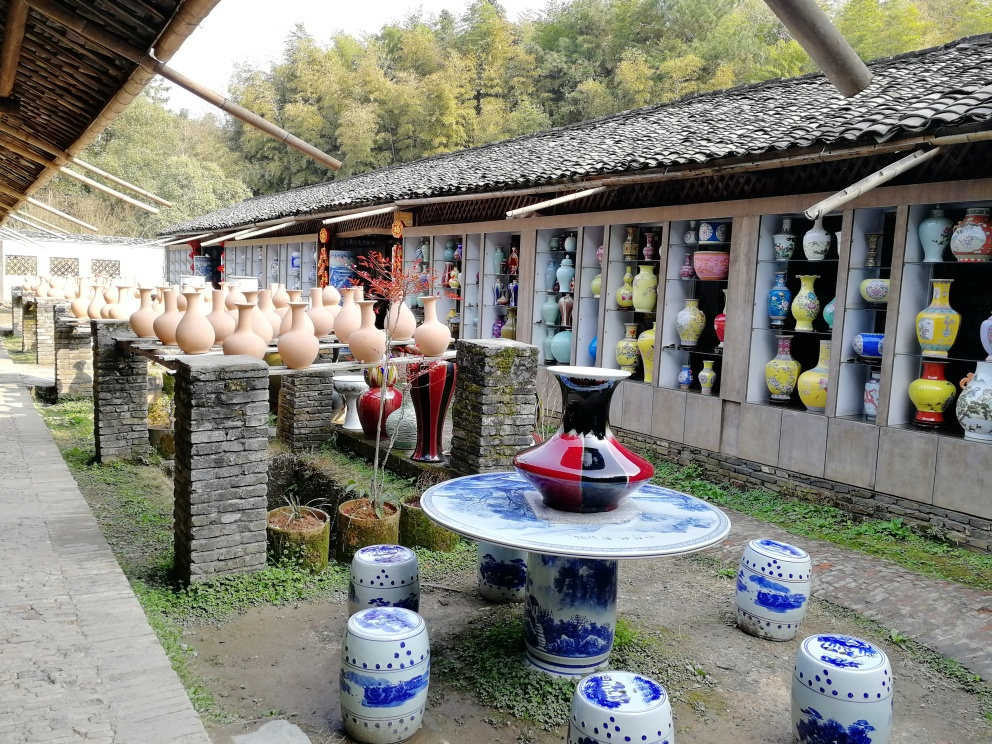What can you tell me about the types of ceramics in this picture? The image displays a variety of ceramics. Foremost are the unglazed, earthenware pots on the stone pillars, which appear functional and ready for practical use. In contrast, inside the building, there are glazed and intricately painted vases, some with floral motifs and others with more abstract designs, indicating a level of artistic skill and possibly suggesting these are for decorative purposes. The blue and white porcelain pieces, specifically the garden stools and table, are indicative of a style famous in Chinese ceramics, characterized by cobalt-blue designs on a white background, a style that is appreciated around the world for its beauty and elegance. 